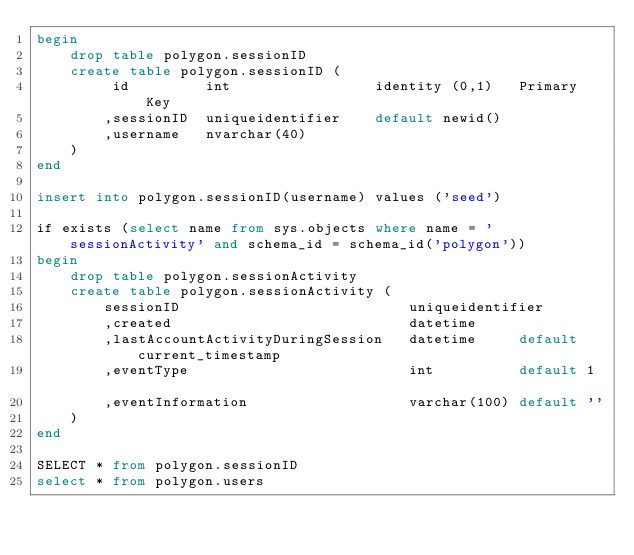Convert code to text. <code><loc_0><loc_0><loc_500><loc_500><_SQL_>begin
	drop table polygon.sessionID
	create table polygon.sessionID (
		 id			int					identity (0,1)	 Primary Key
		,sessionID	uniqueidentifier	default newid()
		,username	nvarchar(40)
	)
end
 
insert into polygon.sessionID(username) values ('seed')

if exists (select name from sys.objects where name = 'sessionActivity' and schema_id = schema_id('polygon'))
begin
	drop table polygon.sessionActivity
	create table polygon.sessionActivity (
		sessionID							uniqueidentifier
		,created							datetime	 
		,lastAccountActivityDuringSession	datetime	 default current_timestamp
		,eventType							int			 default 1				
		,eventInformation					varchar(100) default ''  
	)
end

SELECT * from polygon.sessionID
select * from polygon.users	

</code> 